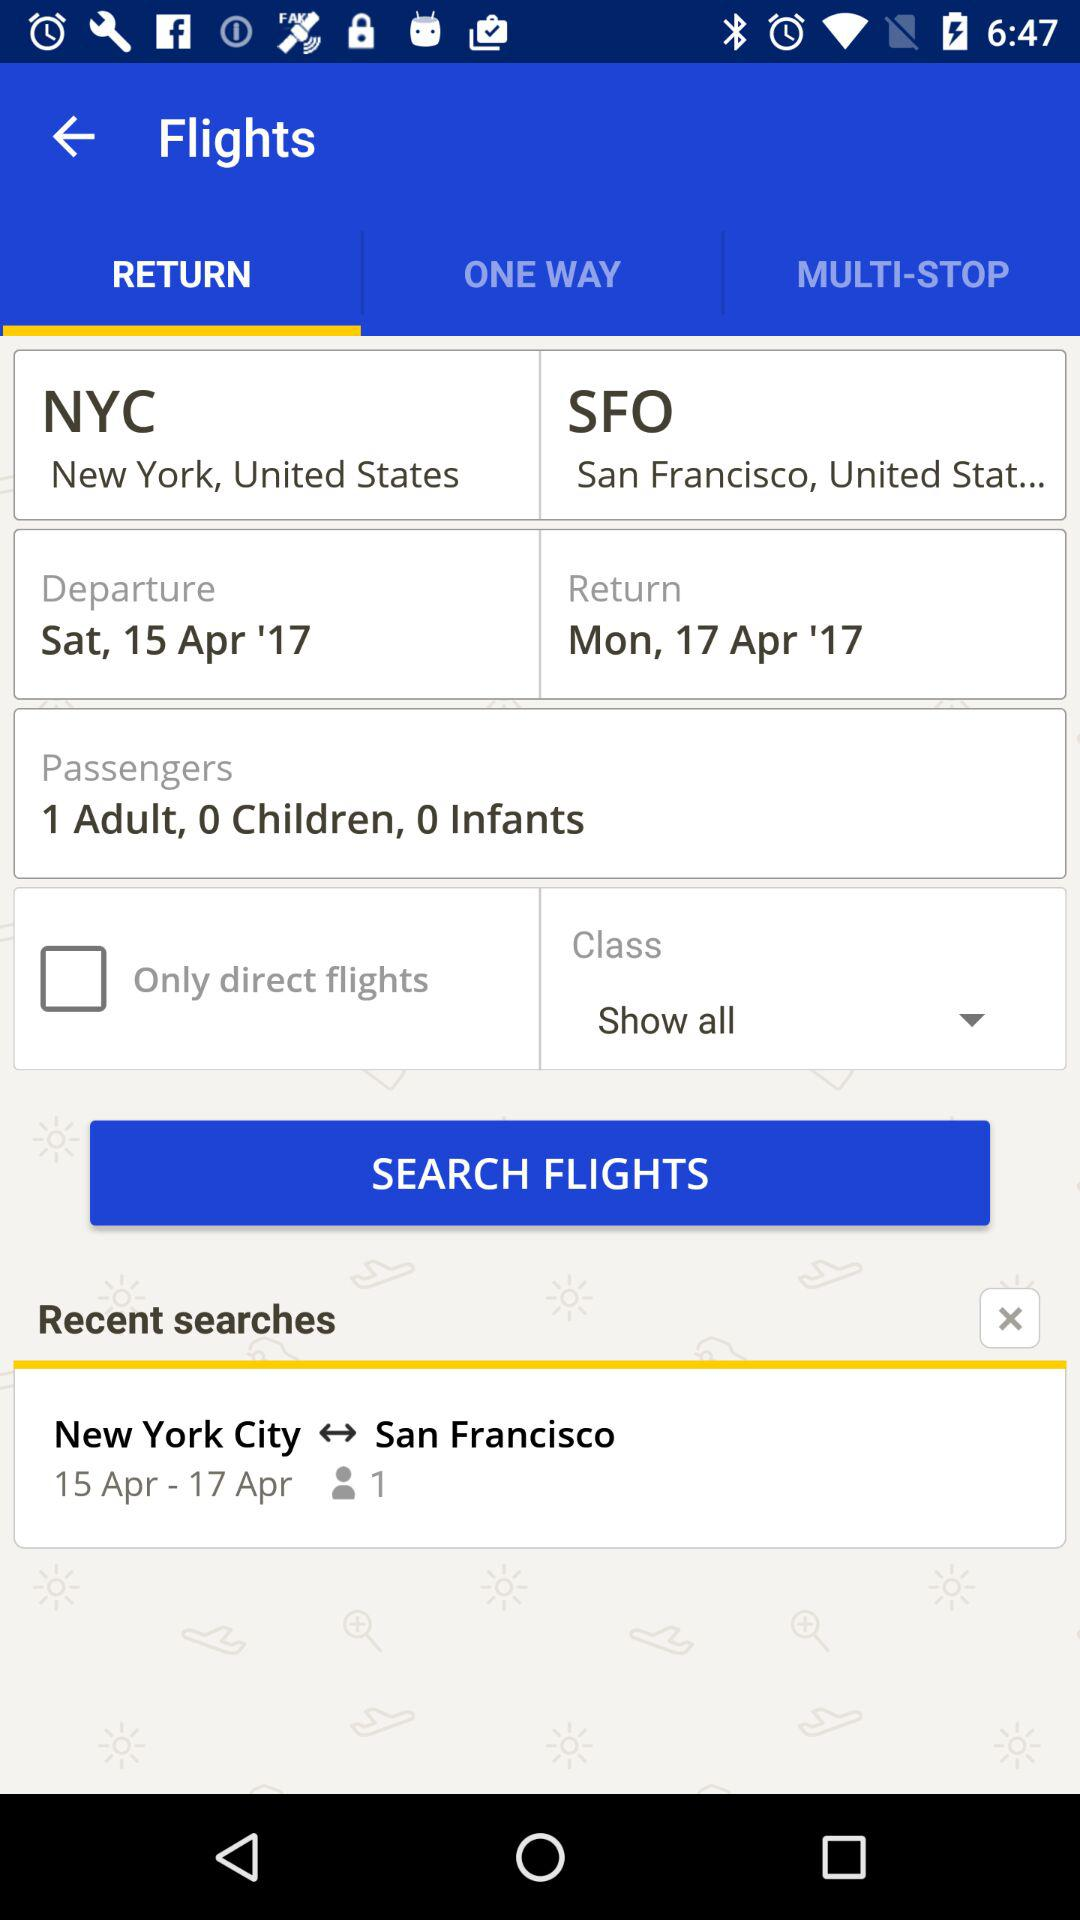How many passengers are there? There is 1 passenger. 